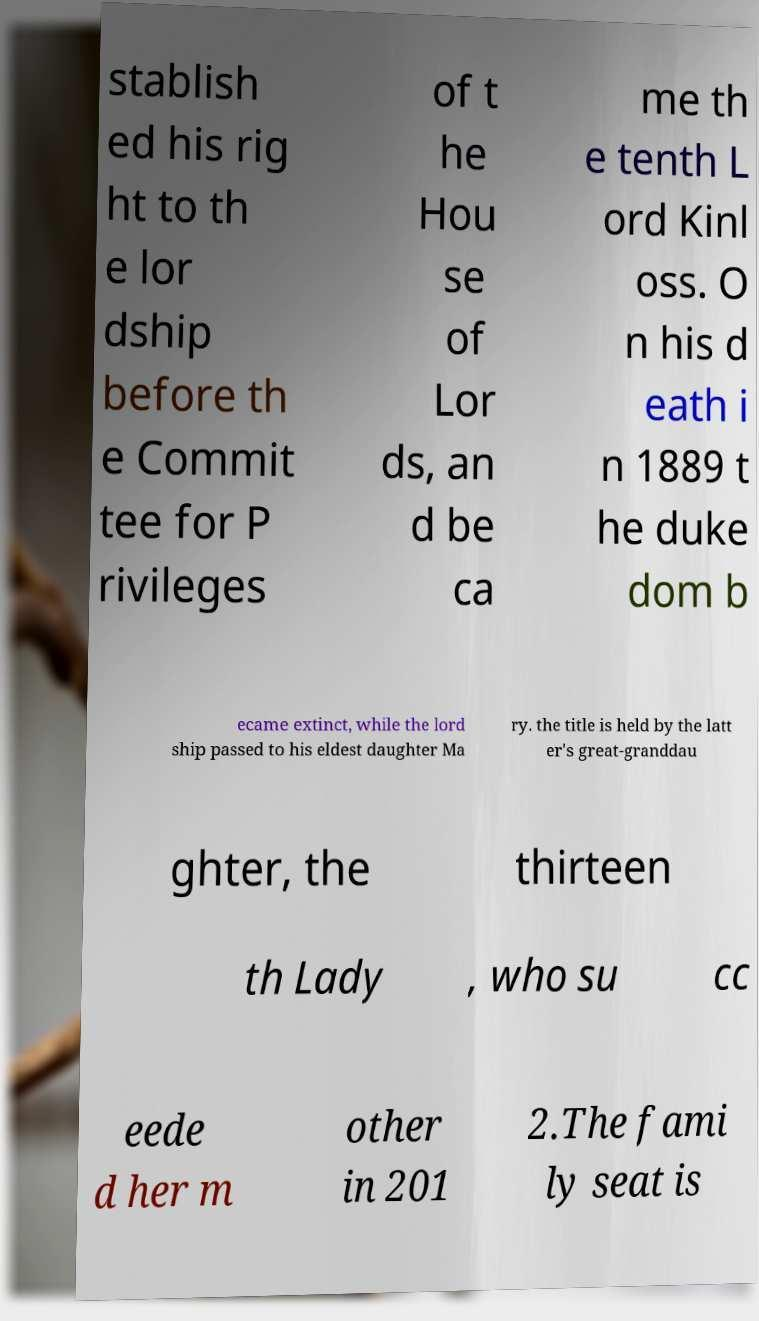For documentation purposes, I need the text within this image transcribed. Could you provide that? stablish ed his rig ht to th e lor dship before th e Commit tee for P rivileges of t he Hou se of Lor ds, an d be ca me th e tenth L ord Kinl oss. O n his d eath i n 1889 t he duke dom b ecame extinct, while the lord ship passed to his eldest daughter Ma ry. the title is held by the latt er's great-granddau ghter, the thirteen th Lady , who su cc eede d her m other in 201 2.The fami ly seat is 